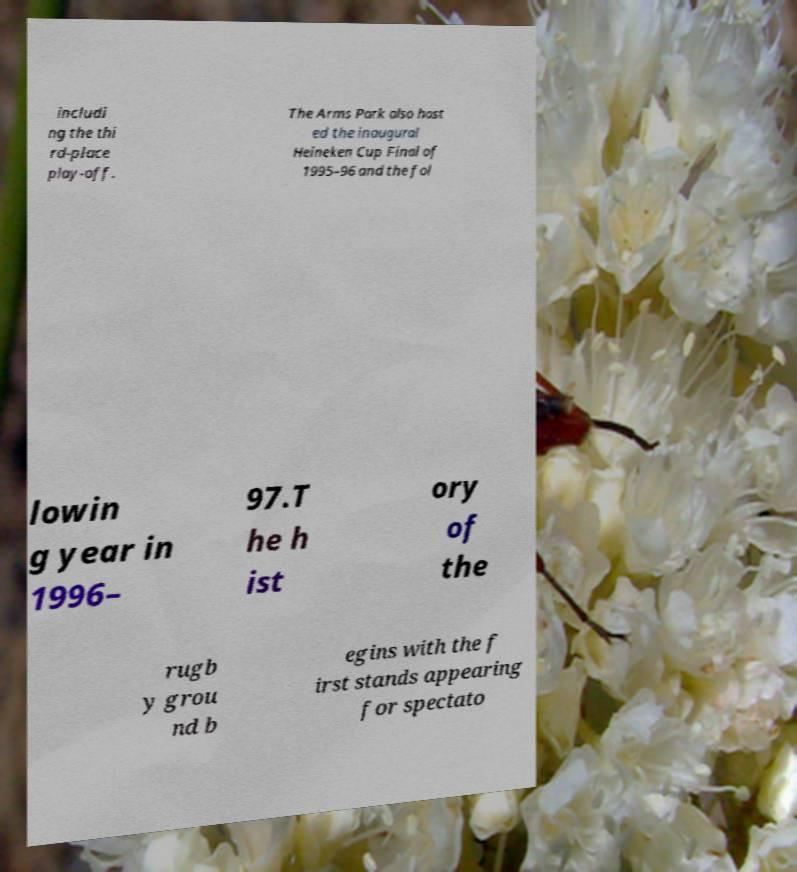Can you accurately transcribe the text from the provided image for me? includi ng the thi rd-place play-off. The Arms Park also host ed the inaugural Heineken Cup Final of 1995–96 and the fol lowin g year in 1996– 97.T he h ist ory of the rugb y grou nd b egins with the f irst stands appearing for spectato 